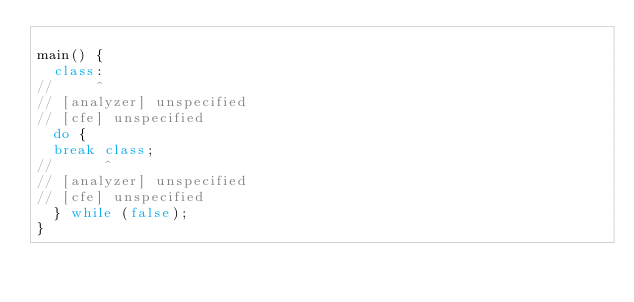<code> <loc_0><loc_0><loc_500><loc_500><_Dart_>
main() {
  class:
//     ^
// [analyzer] unspecified
// [cfe] unspecified
  do {
  break class;
//      ^
// [analyzer] unspecified
// [cfe] unspecified
  } while (false);
}
</code> 